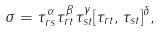<formula> <loc_0><loc_0><loc_500><loc_500>\sigma = \tau _ { r s } ^ { \alpha } \tau _ { r t } ^ { \beta } \tau _ { s t } ^ { \gamma } [ \tau _ { r t } , \tau _ { s t } ] ^ { \delta } ,</formula> 